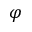Convert formula to latex. <formula><loc_0><loc_0><loc_500><loc_500>\varphi</formula> 